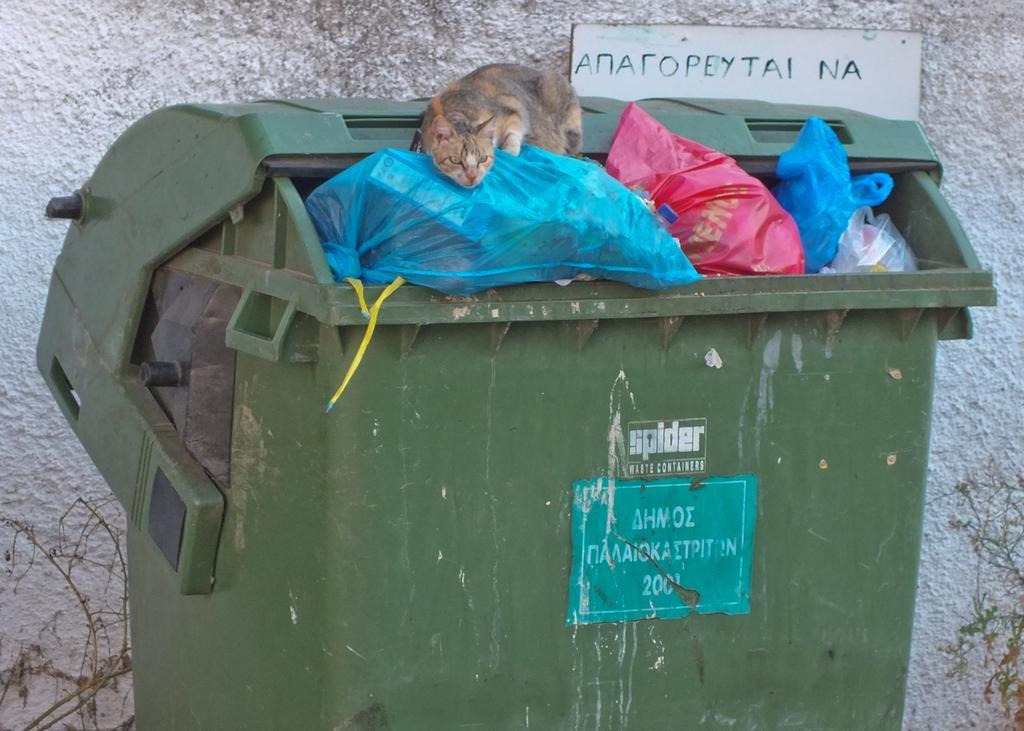Describe this image in one or two sentences. In this image there is a cat on top of trash in a trash bin, behind the bin there is a name board on the wall, on the bottom left and right of the image there are plants. 